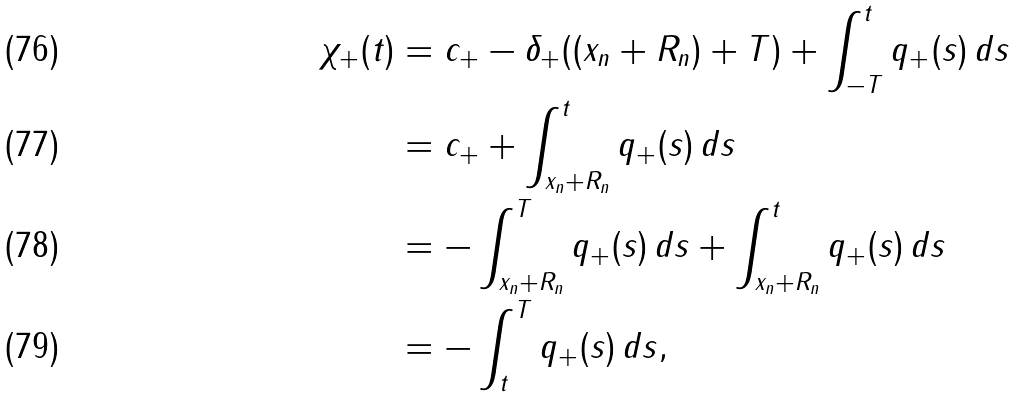Convert formula to latex. <formula><loc_0><loc_0><loc_500><loc_500>\chi _ { + } ( t ) & = c _ { + } - \delta _ { + } ( ( x _ { n } + R _ { n } ) + T ) + \int _ { - T } ^ { t } q _ { + } ( s ) \, d s \\ & = c _ { + } + \int _ { x _ { n } + R _ { n } } ^ { t } q _ { + } ( s ) \, d s \\ & = - \int _ { x _ { n } + R _ { n } } ^ { T } q _ { + } ( s ) \, d s + \int _ { x _ { n } + R _ { n } } ^ { t } q _ { + } ( s ) \, d s \\ & = - \int _ { t } ^ { T } q _ { + } ( s ) \, d s ,</formula> 